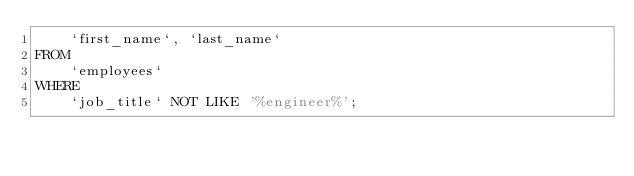Convert code to text. <code><loc_0><loc_0><loc_500><loc_500><_SQL_>    `first_name`, `last_name`
FROM
    `employees`
WHERE
    `job_title` NOT LIKE '%engineer%';</code> 